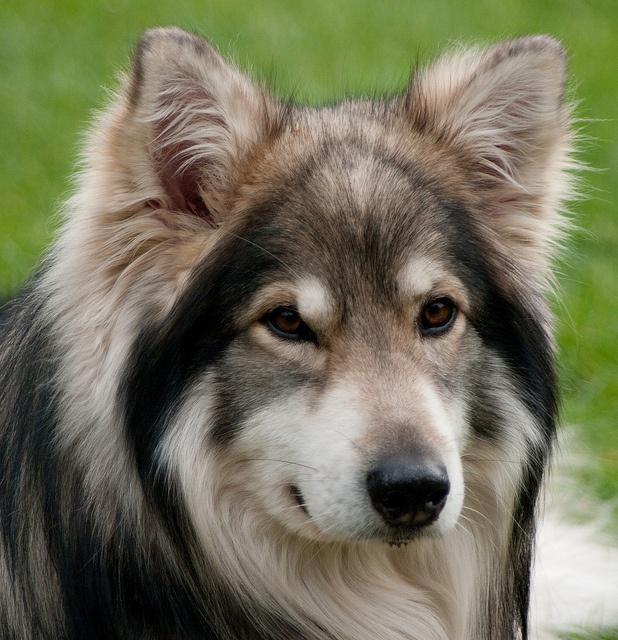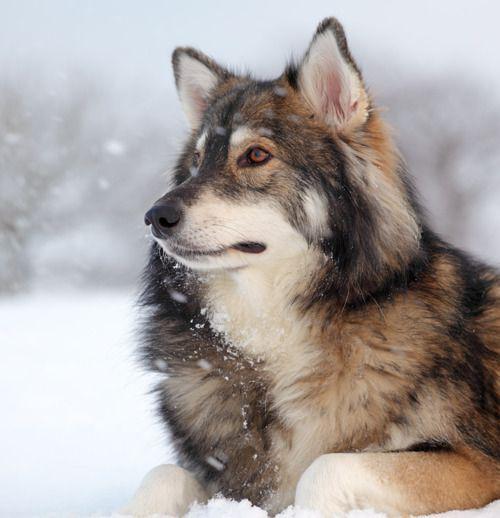The first image is the image on the left, the second image is the image on the right. Considering the images on both sides, is "The left and right image contains the same number of dogs pointed in opposite directions." valid? Answer yes or no. Yes. The first image is the image on the left, the second image is the image on the right. Given the left and right images, does the statement "Two dogs are in snow." hold true? Answer yes or no. No. 